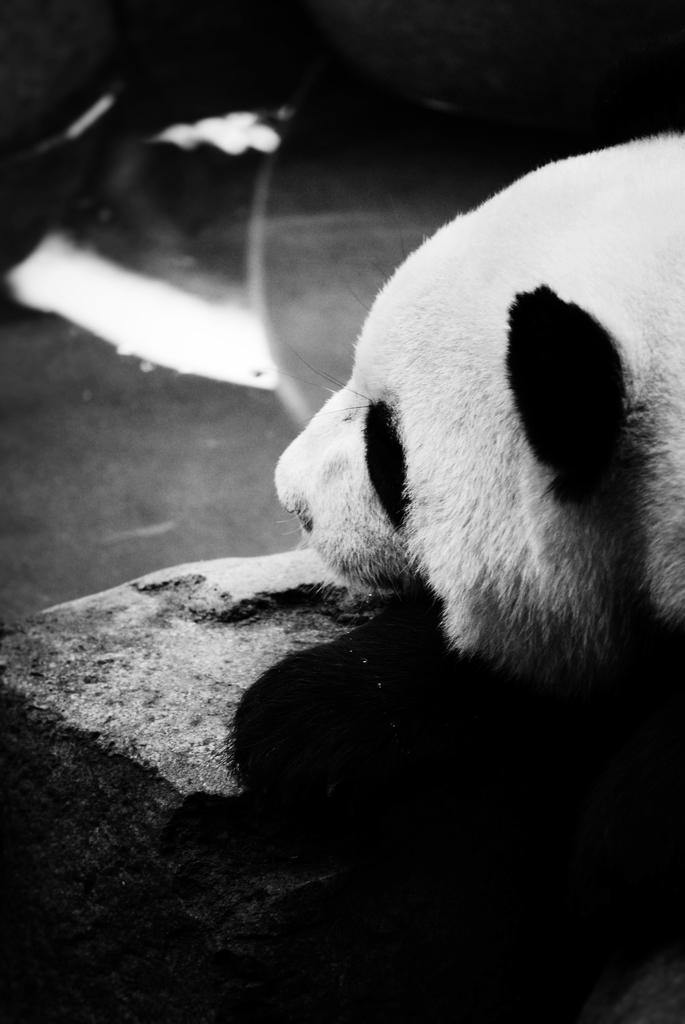Describe this image in one or two sentences. It is a black and white image, it seems like there is a panda and in front of the panda there is a stone. 